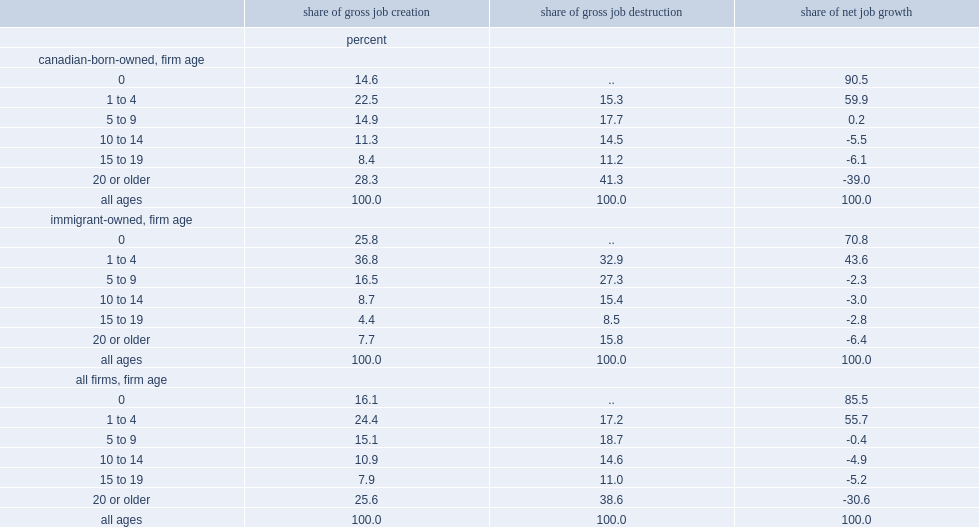What was the percent of older firms accounted for of all gross job gains? 25.6. What was the percent of older firms accounted for of all gross job losses? 38.6. 